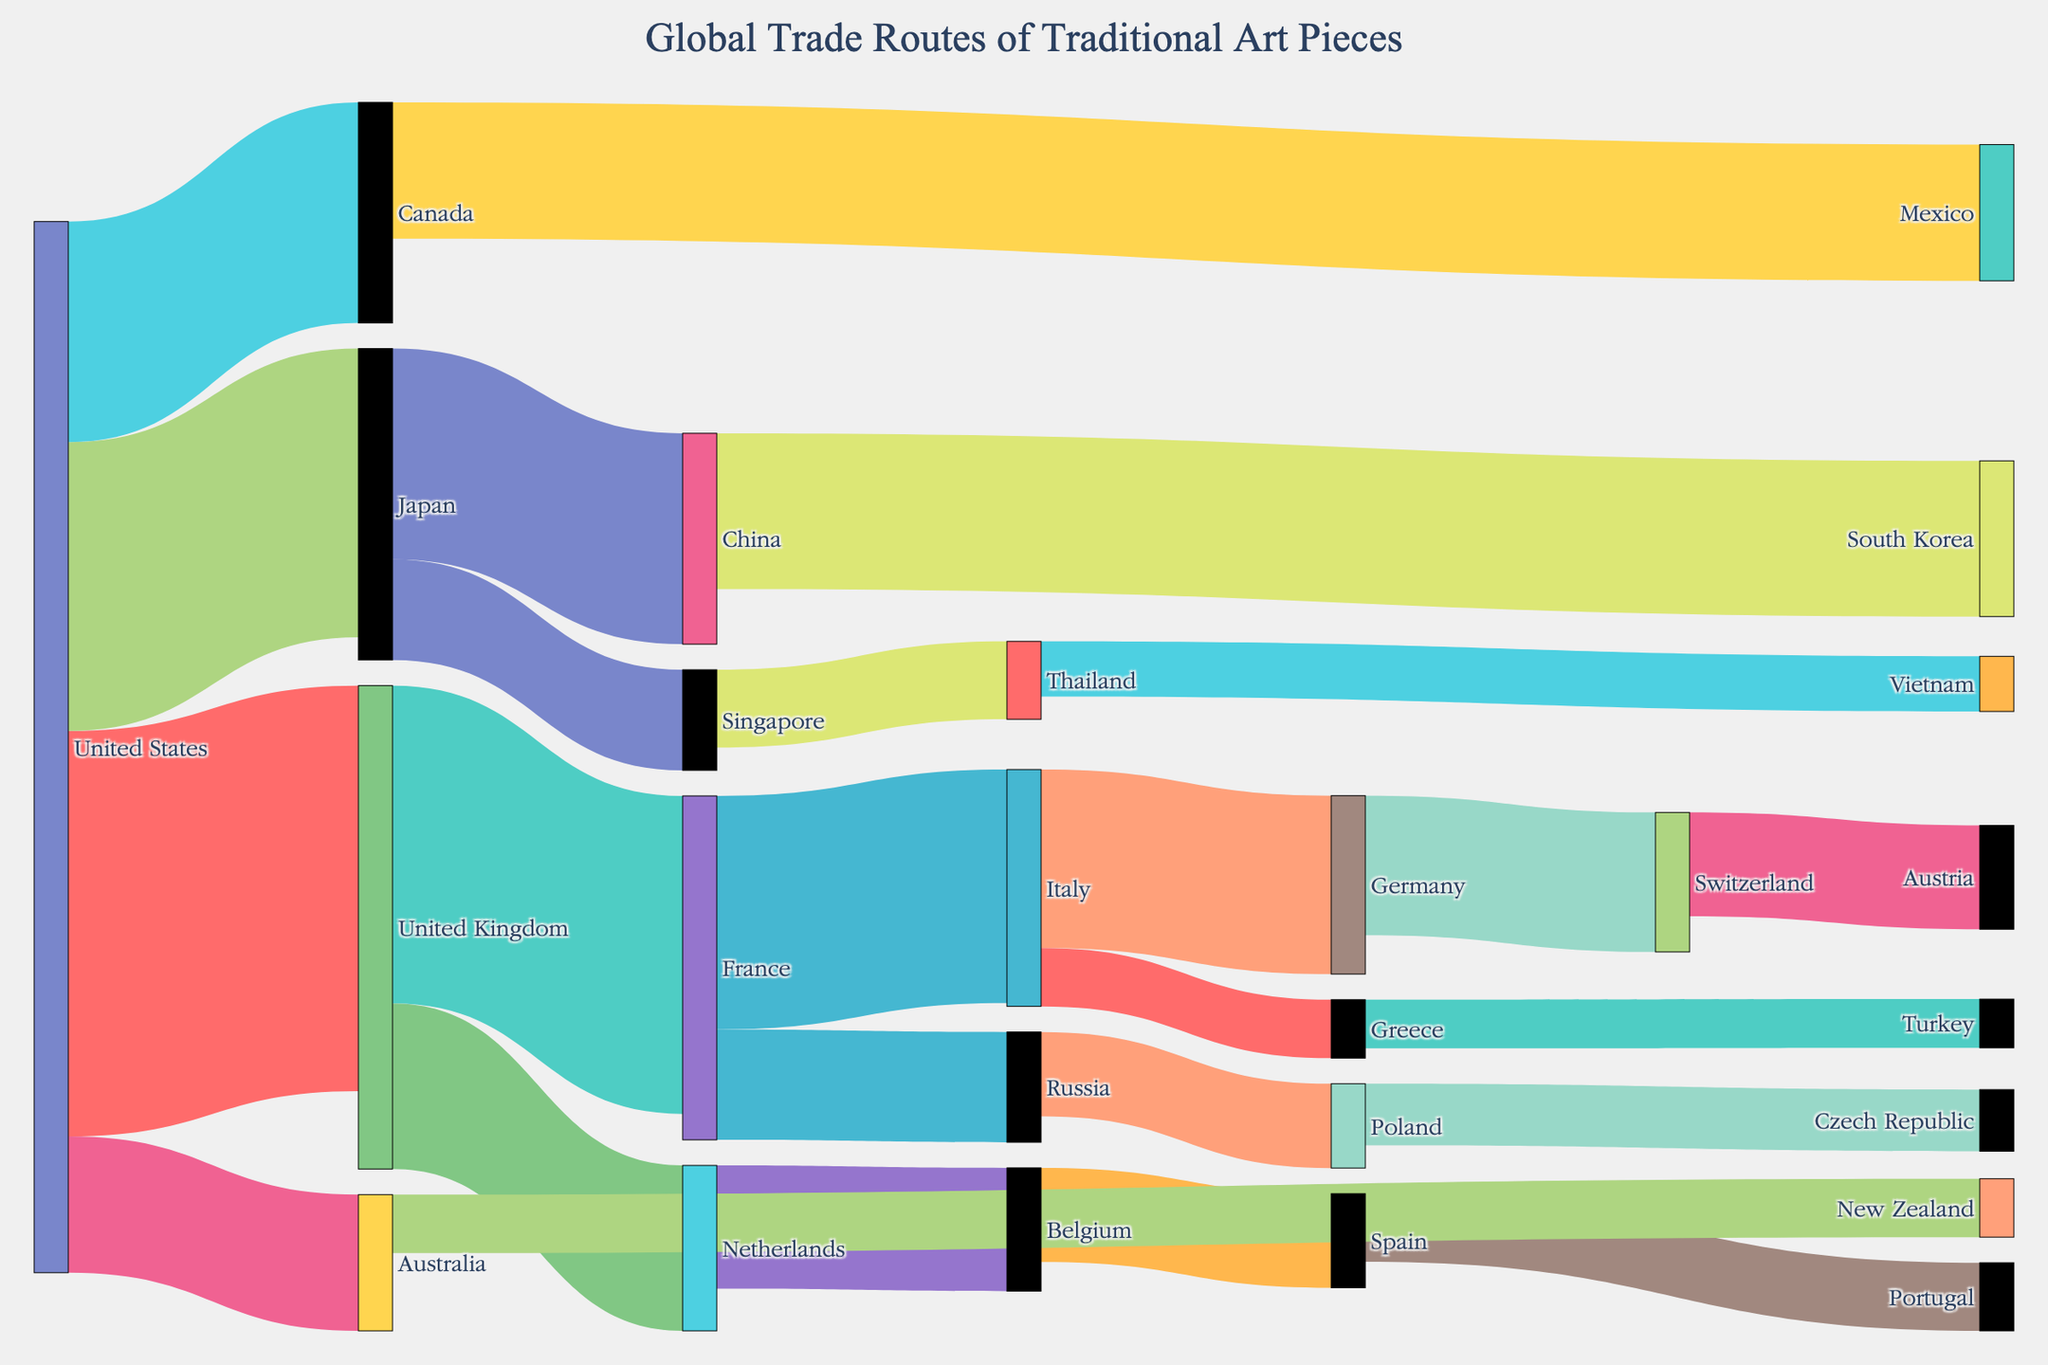What is the total flow going from the United States to other countries? To find the total flow from the United States to other countries, sum the values of all links originating from the United States. These links are: United States to United Kingdom (1250), United States to Japan (890), United States to Canada (680), United States to Australia (420). Summing these gives 1250 + 890 + 680 + 420 = 3240.
Answer: 3240 Which country has the highest number of outgoing trade routes? By counting the outgoing links for each country, we can see that the United States has the highest number with four outgoing routes: to the United Kingdom, Japan, Canada, and Australia.
Answer: United States Which country is directly connected to the most number of other countries as a target? By counting the incoming links for each country, the United Kingdom emerges with the highest number of incoming connections from the United States (1250) and Netherlands (510). This total is 1250 + 510 = 1760, the most of any target.
Answer: United Kingdom What is the smallest direct trade value in the diagram? By examining the values of all the links in the diagram, the smallest value is 150, which corresponds to the trade route from Greece to Turkey.
Answer: 150 How does the volume of trade from the United States to the United Kingdom compare to that from the United States to Japan? The trade volume from the United States to the United Kingdom is 1250, while the volume to Japan is 890. Comparing these two, 1250 is greater than 890.
Answer: United States to United Kingdom > United States to Japan What is the cumulative trade value for all routes terminating in Germany? To determine the cumulative trade value for Germany, sum the values of the incoming links: from Italy (550). Thus, the total is 550.
Answer: 550 What's the difference in trade value between the largest and the smallest trade routes? The largest trade value is 1250 (United States to United Kingdom) and the smallest is 150 (Greece to Turkey). The difference is 1250 - 150 = 1100.
Answer: 1100 How many countries have exactly two direct trading partners? Countries with exactly two direct trading partners are: France (Italy and Russia), Japan (China and Singapore), and United States (Canada and Australia). Thus, the total is three countries.
Answer: 3 What is the total value of the trade routes that involve European countries only? The European trade routes and their values are: United Kingdom to France (980), France to Italy (720), Italy to Germany (550), Germany to Switzerland (430), Switzerland to Austria (320), United Kingdom to Netherlands (510), Netherlands to Belgium (380), Belgium to Spain (290), Spain to Portugal (210), Italy to Greece (180), Greece to Turkey (150), and France to Russia (340). Summing these values gives: 980 + 720 + 550 + 430 + 320 + 510 + 380 + 290 + 210 + 180 + 150 + 340 = 5060.
Answer: 5060 